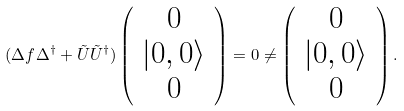<formula> <loc_0><loc_0><loc_500><loc_500>( \Delta f \Delta ^ { \dag } + \tilde { U } \tilde { U } ^ { \dag } ) \left ( \begin{array} { c } 0 \\ | 0 , 0 \rangle \\ 0 \end{array} \right ) = 0 \neq \left ( \begin{array} { c } 0 \\ | 0 , 0 \rangle \\ 0 \end{array} \right ) .</formula> 